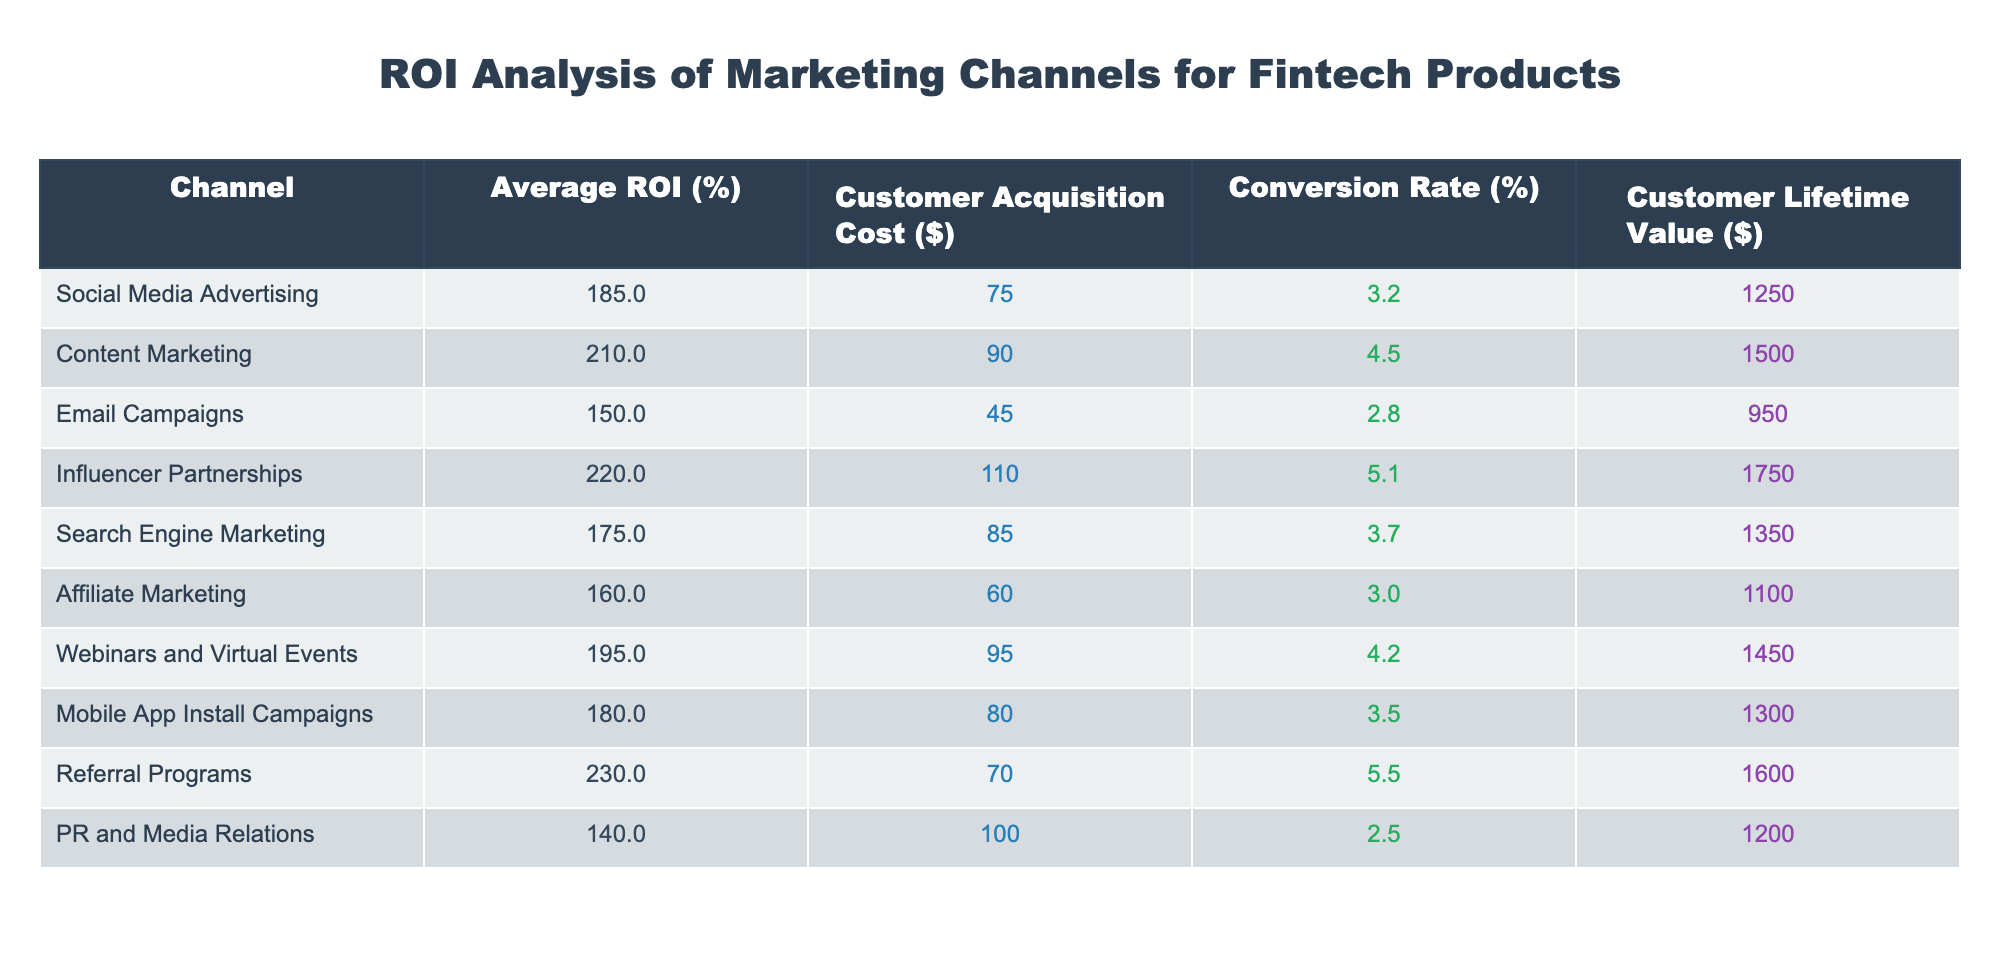What is the highest Customer Acquisition Cost among the marketing channels? Looking at the table, I check the "Customer Acquisition Cost" column and identify the highest value. The maximum is $110, associated with Influencer Partnerships.
Answer: 110 Which marketing channel has the lowest Average ROI? I scan the "Average ROI (%)" column to find the smallest value. The minimum is 140%, linked to PR and Media Relations.
Answer: 140 How much does it cost on average to acquire a customer across all channels? I sum the customer acquisition costs: 75 + 90 + 45 + 110 + 85 + 60 + 95 + 80 + 70 + 100 = 810. There are 10 channels, so the average is 810 / 10 = 81.
Answer: 81 Is the Conversion Rate for Email Campaigns higher than that of Social Media Advertising? I examine the "Conversion Rate (%)" for both channels. Email Campaigns have 2.8% and Social Media Advertising has 3.2%. Since 2.8% is not higher than 3.2%, the statement is false.
Answer: No Which marketing channel provides the highest Customer Lifetime Value? I review the "Customer Lifetime Value ($)" column to find the maximum. The channel with the highest value is Influencer Partnerships at $1750.
Answer: 1750 What is the difference in Average ROI between Referral Programs and Content Marketing? I find the Average ROI for both channels: Referral Programs are 230% and Content Marketing is 210%. The difference is 230 - 210 = 20%.
Answer: 20 Are Social Media Advertising and Mobile App Install Campaigns achieving similar Conversion Rates? I compare the Conversion Rates for both channels. Social Media Advertising has 3.2% and Mobile App Install Campaigns have 3.5%. Since 3.2% is not close to 3.5%, I determine they are not similar.
Answer: No What is the total Customer Lifetime Value of all marketing channels combined? I sum up the Customer Lifetime Values: 1250 + 1500 + 950 + 1750 + 1350 + 1100 + 1450 + 1300 + 1600 + 1200 = 12100.
Answer: 12100 What channel has the best combination of high Average ROI and low Customer Acquisition Cost? I need to analyze both these factors. Referral Programs have the highest ROI at 230% but the cost is $70, whereas Content Marketing has a solid ROI of 210% but costs $90. The Referral Program has the best combination of high ROI and low cost.
Answer: Referral Programs 